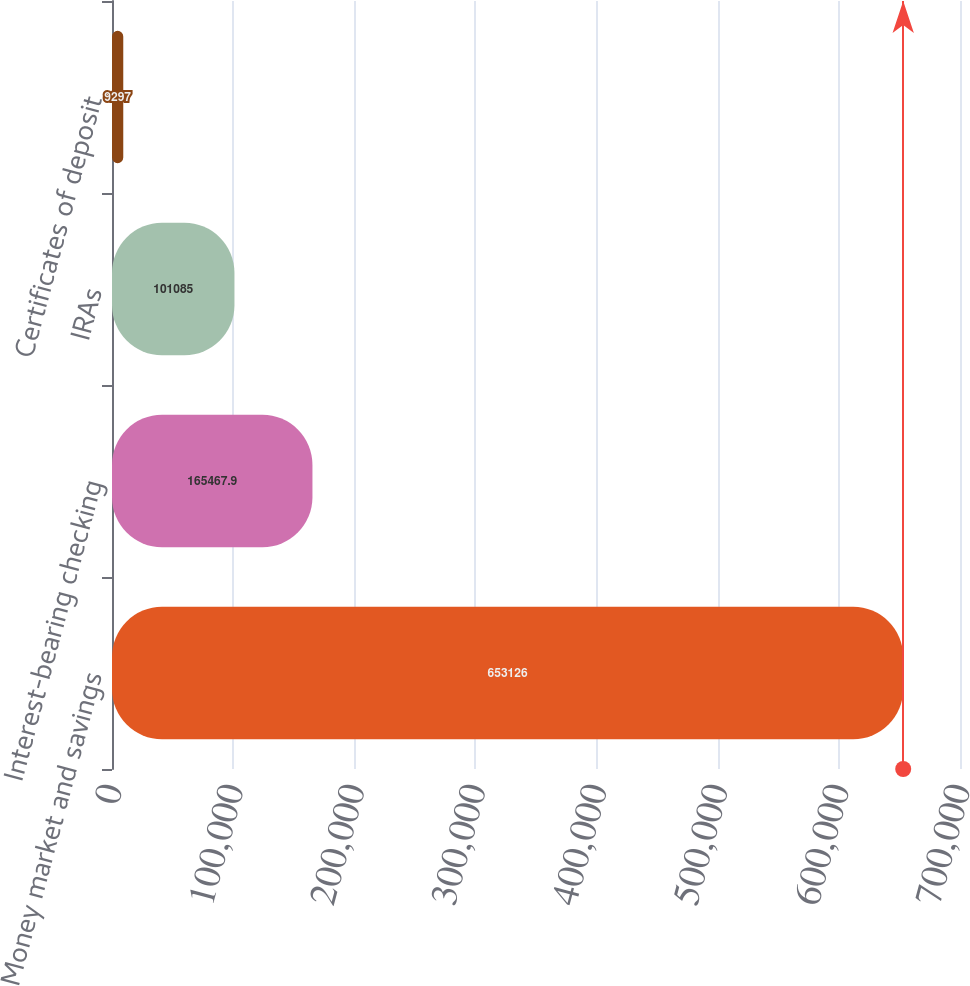Convert chart to OTSL. <chart><loc_0><loc_0><loc_500><loc_500><bar_chart><fcel>Money market and savings<fcel>Interest-bearing checking<fcel>IRAs<fcel>Certificates of deposit<nl><fcel>653126<fcel>165468<fcel>101085<fcel>9297<nl></chart> 